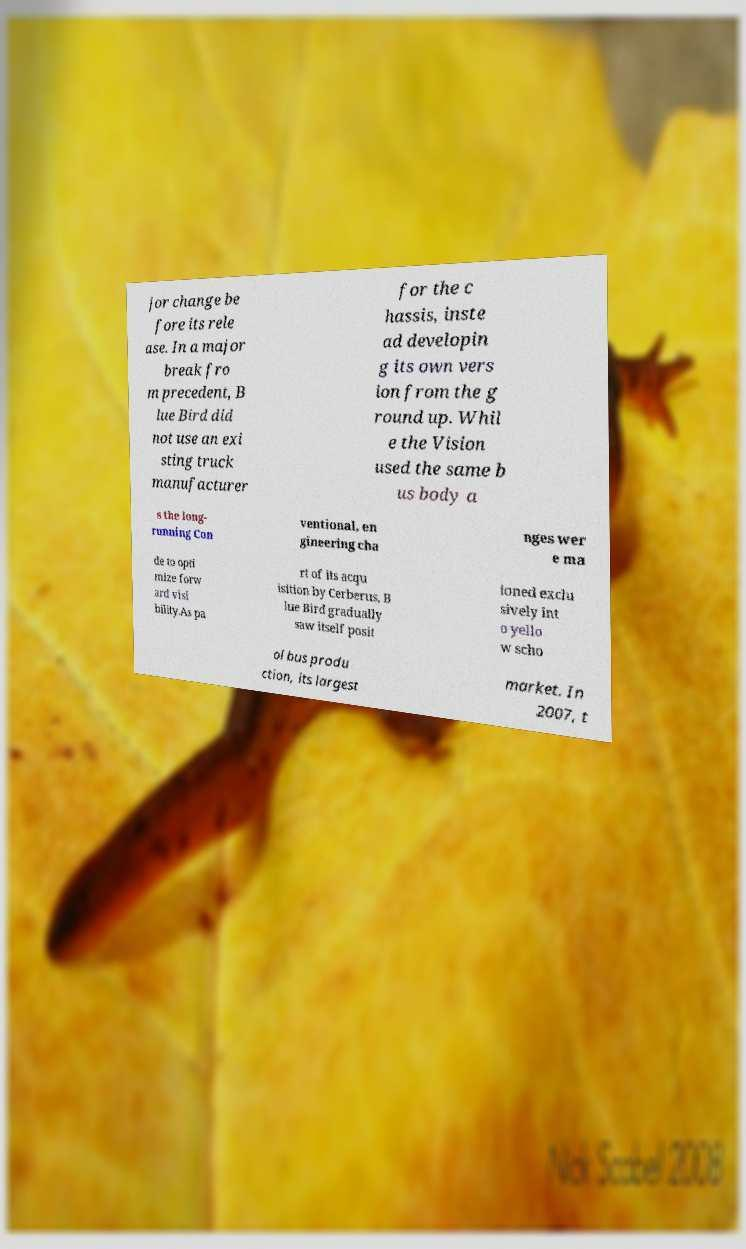Could you assist in decoding the text presented in this image and type it out clearly? jor change be fore its rele ase. In a major break fro m precedent, B lue Bird did not use an exi sting truck manufacturer for the c hassis, inste ad developin g its own vers ion from the g round up. Whil e the Vision used the same b us body a s the long- running Con ventional, en gineering cha nges wer e ma de to opti mize forw ard visi bility.As pa rt of its acqu isition by Cerberus, B lue Bird gradually saw itself posit ioned exclu sively int o yello w scho ol bus produ ction, its largest market. In 2007, t 